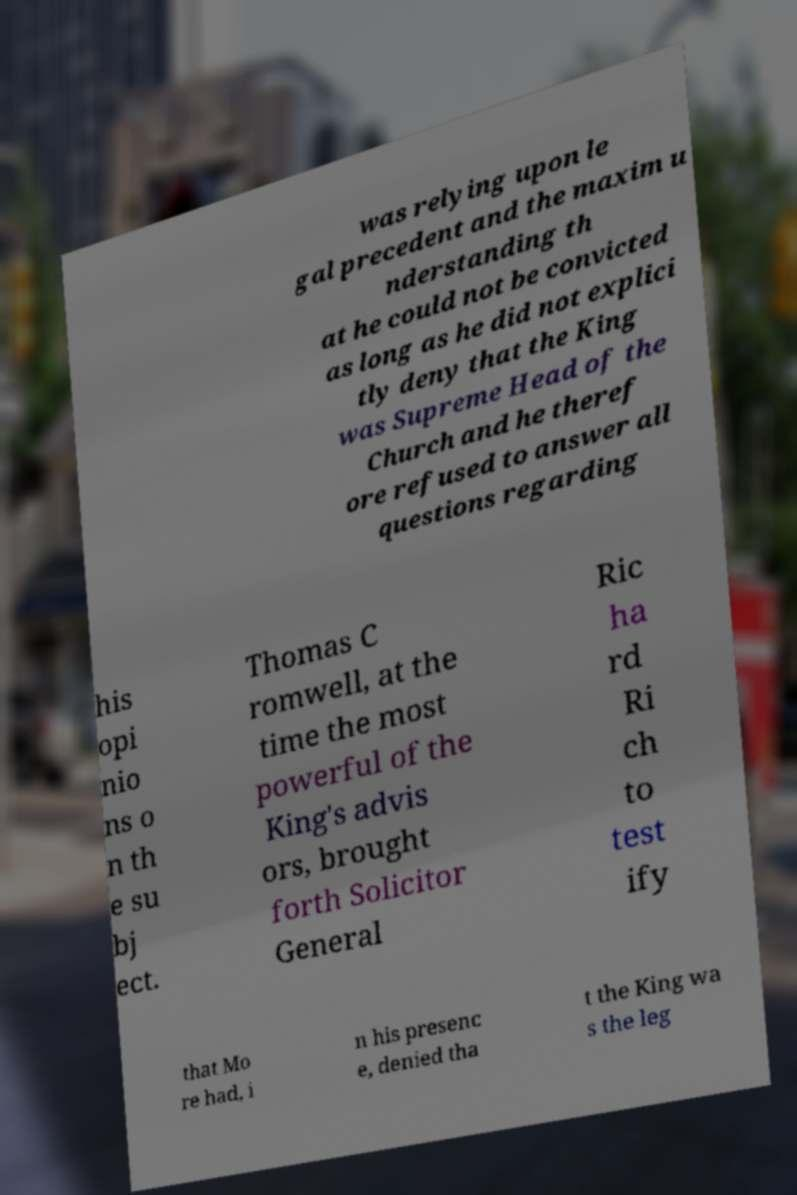Can you read and provide the text displayed in the image?This photo seems to have some interesting text. Can you extract and type it out for me? was relying upon le gal precedent and the maxim u nderstanding th at he could not be convicted as long as he did not explici tly deny that the King was Supreme Head of the Church and he theref ore refused to answer all questions regarding his opi nio ns o n th e su bj ect. Thomas C romwell, at the time the most powerful of the King's advis ors, brought forth Solicitor General Ric ha rd Ri ch to test ify that Mo re had, i n his presenc e, denied tha t the King wa s the leg 